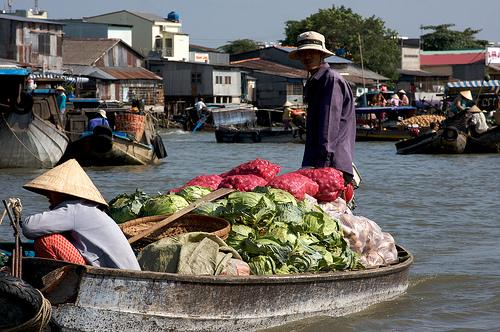For the visible buildings in the image, what is the overall sentiment or feeling they evoke? The visible buildings evoke a rustic and rural feeling due to their close proximity to the water and the presence of rusty aluminum roofs. In the interaction analysis of objects, what are the various objects being used for in this image? Various objects are being used for storage and transport of produce (bags, baskets), navigating through the water (oar), and providing protection from the sun (hats). In the boat, is there any equipment for navigating the water? If so, describe it. Yes, there is a wooden oar used to paddle the boat and navigate through the water. Provide a brief summary of the scene in this image including key objects and their colors. A man in a white hat is standing in a boat filled with colorful produce, surrounded by water. There are green cabbages, red bags, and a large woven basket on the boat. How many boats are on the body of water? There are at least three other boats visible in the water, including a gray boat and a white boat. Identify the prominent colors of the objects in the boat. Red, green, white, and brown are the prominent colors of the objects in the boat. Are there any other people in the image besides the man with the white hat? Yes, there is a woman crouched down in the boat wearing a straw hat and a light blue shirt. How would you describe the type of boat in the image, and what is its primary use? It is a somewhat old and tattered wooden rowboat that appears to be primarily used for transporting produce. Briefly describe the environment surrounding the body of water in the image. The environment surrounding the body of water includes several buildings with rusty roofs, and a large green tree situated behind the buildings. What kind of headwear does the man in the boat wear, and what is its color? The man in the boat is wearing a white, triangle-shaped or pointed hat. What is the object at position X:90 Y:175, and what is its size? The object is a straight oar one, size: Width:150 Height:150. Give the coordinates of the woman wearing the straw hat. X:17 Y:152 Width:95 Height:95. Describe any object interactions or anomalies in the image. The man is steering the boat and the paddle is resting on the basket. No anomalies detected. Which object in the image has the text "red letters" on it? The basket with red letters on it. What are the captions related to boats in the image? The boat is in the water, boat in the water with a large basket, front view of a white boat, boat is in the water, gray boat in the water, and body of water full of boats. Identify the color of the shirt and pants mentioned in the captions. The shirt is dark blue, the pants are orange and white. What position is the large green tree behind the buildings at? X:282 Y:10 Width:117 Height:117. What type of hat is the man wearing? Triangle shaped hat, sedge hat asian conical hat, and pointed hat. Is the boat in the water? Yes, the boat is in the water. What is the pile of vegetables in the boat's position and size? Position: X:100 Y:156 Size: Width:295 Height:295. Which object has the approximate size of Width:73 Height:73 and what is its description? The ore at position X:166 Y:178 is described as wooden. Describe the basket in the image. The basket is of a woven design, sitting in the boat, and topped with red letters. What type of pants is the person in the image wearing? Redwhite patterned pants. Read any text visible in the image. No text is visible in the image. Describe the scene's sentiment and quality. The scene has a calm and busy sentiment with good quality. Is there a person mending the roof onshore? Yes, position X:162 Y:6 Width:20 Height:20. Segment the cabbage in the image. The cabbage is green with position X:235 Y:191 Width:40 Height:40. Identify the color and position of the bag. The bag is red and its position is X:276 Y:170. What color is the bag and what is it made of? The bag is red and material is not specified. 